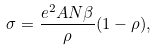Convert formula to latex. <formula><loc_0><loc_0><loc_500><loc_500>\sigma = \frac { e ^ { 2 } A N \beta } \rho ( 1 - \rho ) ,</formula> 